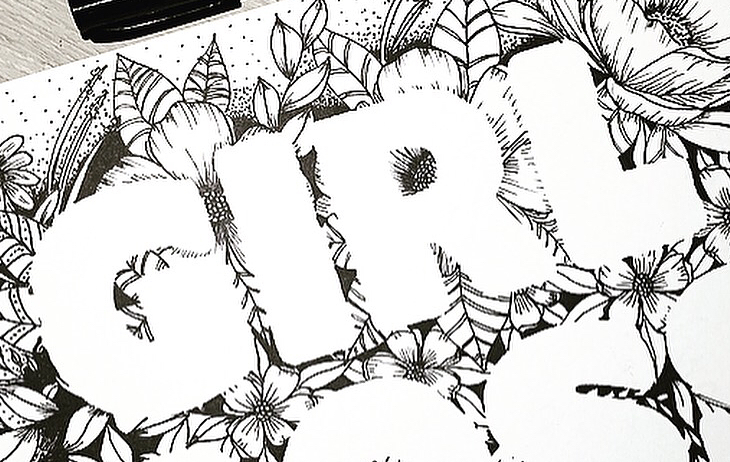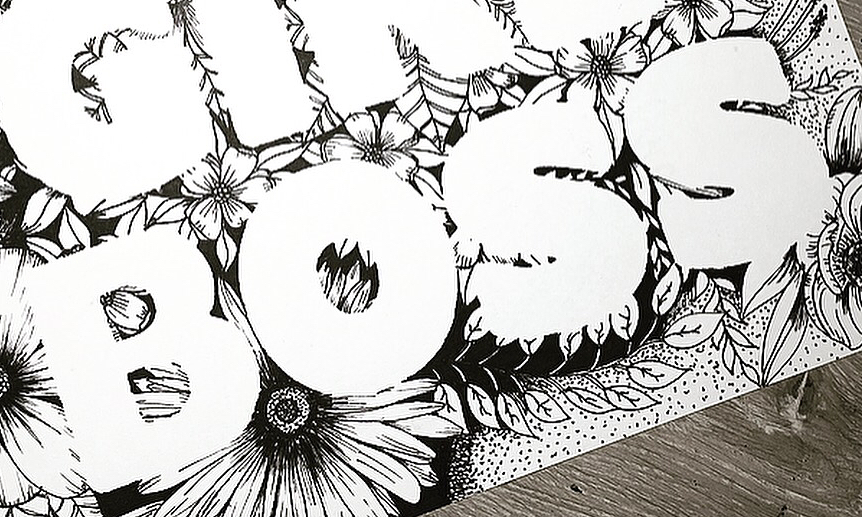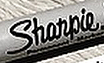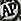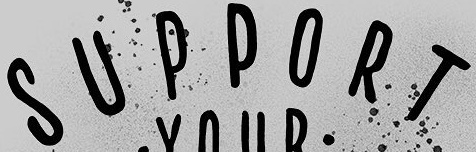Read the text content from these images in order, separated by a semicolon. GIRL; BOSS; Shanpie; AP; SUPPORT 